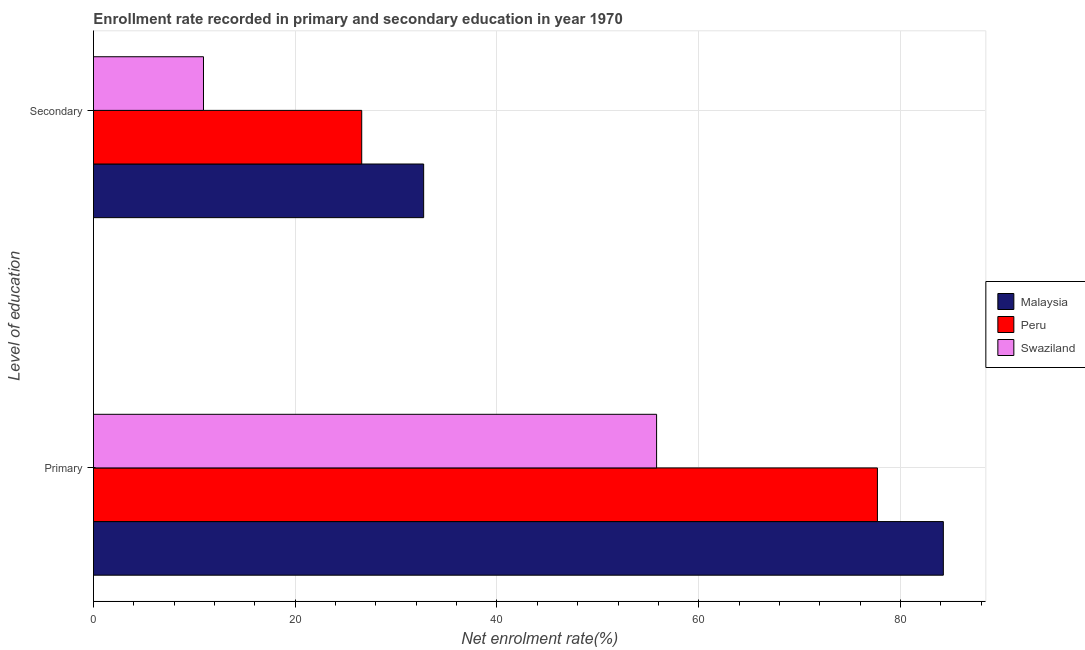How many different coloured bars are there?
Give a very brief answer. 3. Are the number of bars per tick equal to the number of legend labels?
Your answer should be compact. Yes. Are the number of bars on each tick of the Y-axis equal?
Your answer should be compact. Yes. How many bars are there on the 2nd tick from the bottom?
Offer a terse response. 3. What is the label of the 1st group of bars from the top?
Provide a succinct answer. Secondary. What is the enrollment rate in primary education in Peru?
Give a very brief answer. 77.71. Across all countries, what is the maximum enrollment rate in primary education?
Keep it short and to the point. 84.25. Across all countries, what is the minimum enrollment rate in secondary education?
Make the answer very short. 10.9. In which country was the enrollment rate in primary education maximum?
Make the answer very short. Malaysia. In which country was the enrollment rate in secondary education minimum?
Your answer should be compact. Swaziland. What is the total enrollment rate in primary education in the graph?
Keep it short and to the point. 217.78. What is the difference between the enrollment rate in primary education in Malaysia and that in Peru?
Your answer should be compact. 6.53. What is the difference between the enrollment rate in secondary education in Peru and the enrollment rate in primary education in Swaziland?
Offer a very short reply. -29.23. What is the average enrollment rate in primary education per country?
Provide a short and direct response. 72.59. What is the difference between the enrollment rate in secondary education and enrollment rate in primary education in Peru?
Provide a succinct answer. -51.12. What is the ratio of the enrollment rate in primary education in Peru to that in Malaysia?
Your response must be concise. 0.92. In how many countries, is the enrollment rate in secondary education greater than the average enrollment rate in secondary education taken over all countries?
Your answer should be very brief. 2. What does the 1st bar from the top in Primary represents?
Offer a terse response. Swaziland. What does the 2nd bar from the bottom in Secondary represents?
Provide a short and direct response. Peru. Are all the bars in the graph horizontal?
Offer a terse response. Yes. What is the difference between two consecutive major ticks on the X-axis?
Provide a succinct answer. 20. Does the graph contain any zero values?
Ensure brevity in your answer.  No. Where does the legend appear in the graph?
Provide a short and direct response. Center right. How many legend labels are there?
Your answer should be very brief. 3. How are the legend labels stacked?
Provide a succinct answer. Vertical. What is the title of the graph?
Your response must be concise. Enrollment rate recorded in primary and secondary education in year 1970. What is the label or title of the X-axis?
Make the answer very short. Net enrolment rate(%). What is the label or title of the Y-axis?
Offer a very short reply. Level of education. What is the Net enrolment rate(%) in Malaysia in Primary?
Provide a short and direct response. 84.25. What is the Net enrolment rate(%) of Peru in Primary?
Offer a terse response. 77.71. What is the Net enrolment rate(%) of Swaziland in Primary?
Provide a succinct answer. 55.82. What is the Net enrolment rate(%) in Malaysia in Secondary?
Provide a succinct answer. 32.73. What is the Net enrolment rate(%) in Peru in Secondary?
Your answer should be compact. 26.59. What is the Net enrolment rate(%) of Swaziland in Secondary?
Your answer should be compact. 10.9. Across all Level of education, what is the maximum Net enrolment rate(%) of Malaysia?
Your answer should be very brief. 84.25. Across all Level of education, what is the maximum Net enrolment rate(%) of Peru?
Your answer should be very brief. 77.71. Across all Level of education, what is the maximum Net enrolment rate(%) of Swaziland?
Offer a terse response. 55.82. Across all Level of education, what is the minimum Net enrolment rate(%) of Malaysia?
Keep it short and to the point. 32.73. Across all Level of education, what is the minimum Net enrolment rate(%) in Peru?
Make the answer very short. 26.59. Across all Level of education, what is the minimum Net enrolment rate(%) in Swaziland?
Your response must be concise. 10.9. What is the total Net enrolment rate(%) of Malaysia in the graph?
Make the answer very short. 116.98. What is the total Net enrolment rate(%) of Peru in the graph?
Give a very brief answer. 104.3. What is the total Net enrolment rate(%) of Swaziland in the graph?
Keep it short and to the point. 66.73. What is the difference between the Net enrolment rate(%) of Malaysia in Primary and that in Secondary?
Ensure brevity in your answer.  51.51. What is the difference between the Net enrolment rate(%) of Peru in Primary and that in Secondary?
Your response must be concise. 51.12. What is the difference between the Net enrolment rate(%) of Swaziland in Primary and that in Secondary?
Give a very brief answer. 44.92. What is the difference between the Net enrolment rate(%) in Malaysia in Primary and the Net enrolment rate(%) in Peru in Secondary?
Keep it short and to the point. 57.65. What is the difference between the Net enrolment rate(%) of Malaysia in Primary and the Net enrolment rate(%) of Swaziland in Secondary?
Your answer should be very brief. 73.34. What is the difference between the Net enrolment rate(%) in Peru in Primary and the Net enrolment rate(%) in Swaziland in Secondary?
Your answer should be very brief. 66.81. What is the average Net enrolment rate(%) in Malaysia per Level of education?
Give a very brief answer. 58.49. What is the average Net enrolment rate(%) in Peru per Level of education?
Provide a short and direct response. 52.15. What is the average Net enrolment rate(%) in Swaziland per Level of education?
Your answer should be compact. 33.36. What is the difference between the Net enrolment rate(%) of Malaysia and Net enrolment rate(%) of Peru in Primary?
Your answer should be very brief. 6.53. What is the difference between the Net enrolment rate(%) in Malaysia and Net enrolment rate(%) in Swaziland in Primary?
Keep it short and to the point. 28.42. What is the difference between the Net enrolment rate(%) in Peru and Net enrolment rate(%) in Swaziland in Primary?
Your answer should be compact. 21.89. What is the difference between the Net enrolment rate(%) in Malaysia and Net enrolment rate(%) in Peru in Secondary?
Ensure brevity in your answer.  6.14. What is the difference between the Net enrolment rate(%) in Malaysia and Net enrolment rate(%) in Swaziland in Secondary?
Your answer should be compact. 21.83. What is the difference between the Net enrolment rate(%) of Peru and Net enrolment rate(%) of Swaziland in Secondary?
Give a very brief answer. 15.69. What is the ratio of the Net enrolment rate(%) in Malaysia in Primary to that in Secondary?
Your answer should be very brief. 2.57. What is the ratio of the Net enrolment rate(%) of Peru in Primary to that in Secondary?
Give a very brief answer. 2.92. What is the ratio of the Net enrolment rate(%) in Swaziland in Primary to that in Secondary?
Your answer should be compact. 5.12. What is the difference between the highest and the second highest Net enrolment rate(%) in Malaysia?
Keep it short and to the point. 51.51. What is the difference between the highest and the second highest Net enrolment rate(%) in Peru?
Your answer should be compact. 51.12. What is the difference between the highest and the second highest Net enrolment rate(%) in Swaziland?
Provide a short and direct response. 44.92. What is the difference between the highest and the lowest Net enrolment rate(%) in Malaysia?
Keep it short and to the point. 51.51. What is the difference between the highest and the lowest Net enrolment rate(%) in Peru?
Ensure brevity in your answer.  51.12. What is the difference between the highest and the lowest Net enrolment rate(%) of Swaziland?
Offer a very short reply. 44.92. 